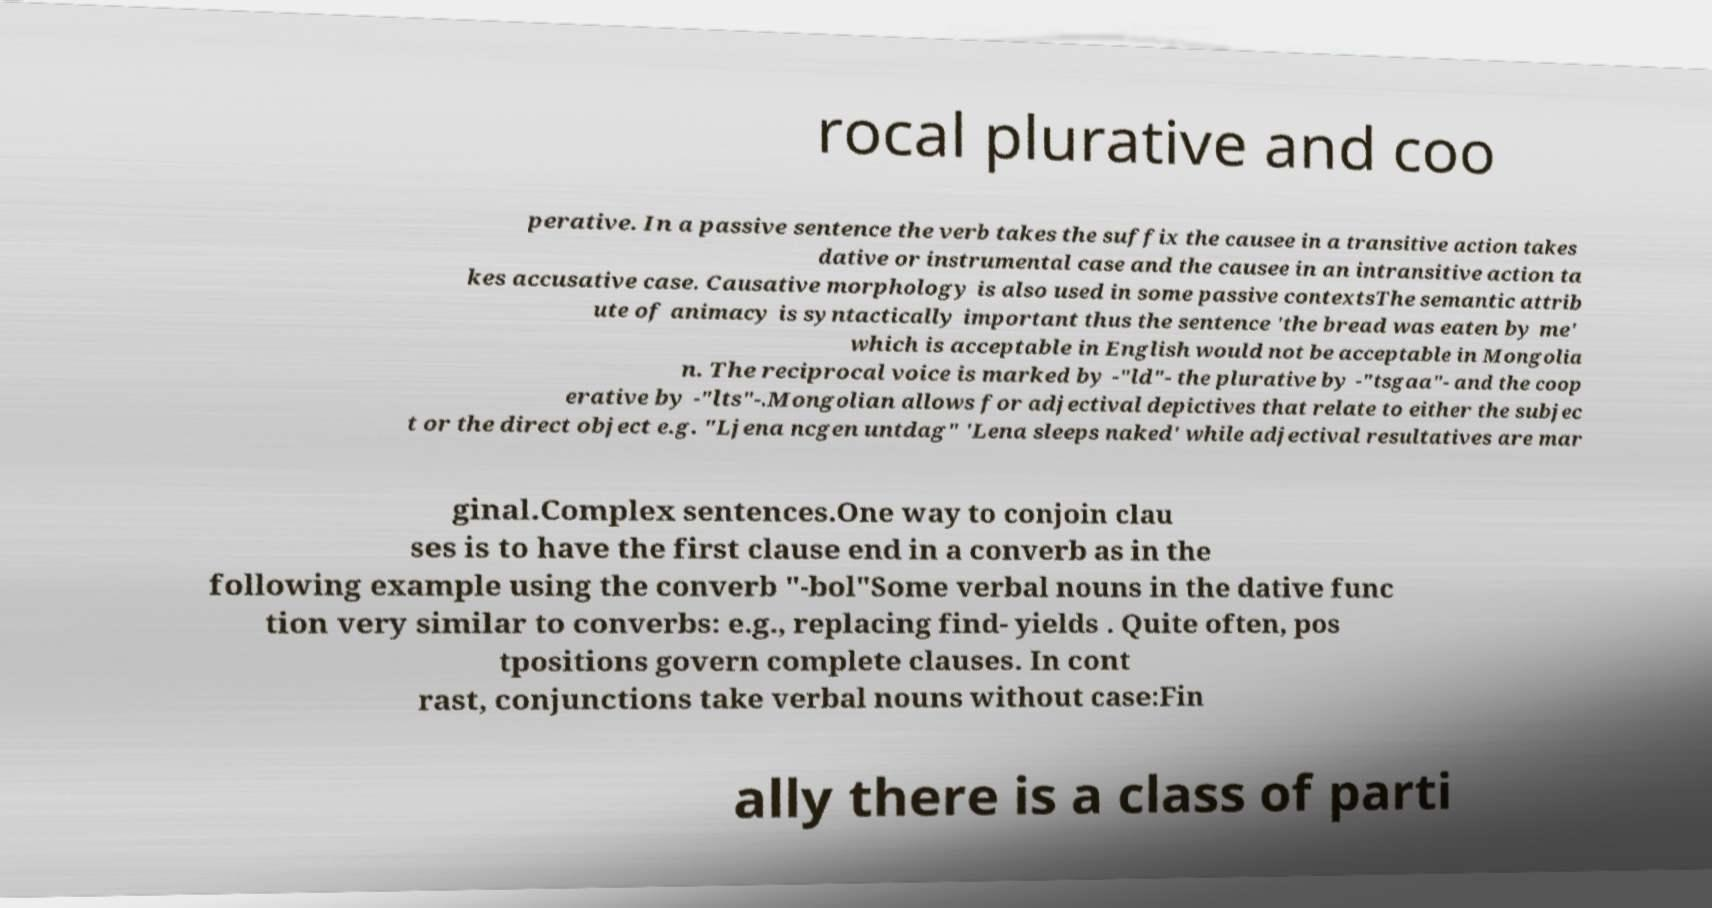For documentation purposes, I need the text within this image transcribed. Could you provide that? rocal plurative and coo perative. In a passive sentence the verb takes the suffix the causee in a transitive action takes dative or instrumental case and the causee in an intransitive action ta kes accusative case. Causative morphology is also used in some passive contextsThe semantic attrib ute of animacy is syntactically important thus the sentence 'the bread was eaten by me' which is acceptable in English would not be acceptable in Mongolia n. The reciprocal voice is marked by -"ld"- the plurative by -"tsgaa"- and the coop erative by -"lts"-.Mongolian allows for adjectival depictives that relate to either the subjec t or the direct object e.g. "Ljena ncgen untdag" 'Lena sleeps naked' while adjectival resultatives are mar ginal.Complex sentences.One way to conjoin clau ses is to have the first clause end in a converb as in the following example using the converb "-bol"Some verbal nouns in the dative func tion very similar to converbs: e.g., replacing find- yields . Quite often, pos tpositions govern complete clauses. In cont rast, conjunctions take verbal nouns without case:Fin ally there is a class of parti 